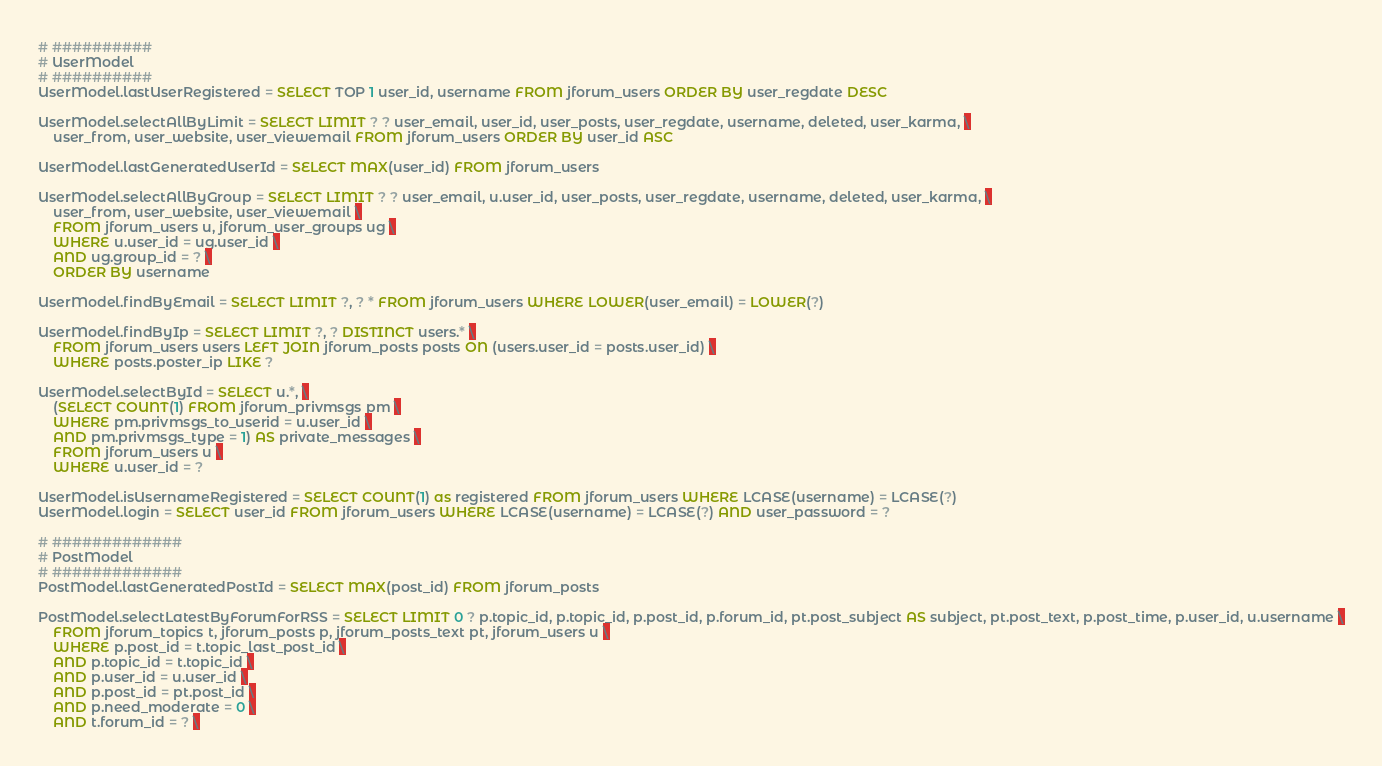Convert code to text. <code><loc_0><loc_0><loc_500><loc_500><_SQL_># ##########
# UserModel
# ##########
UserModel.lastUserRegistered = SELECT TOP 1 user_id, username FROM jforum_users ORDER BY user_regdate DESC 

UserModel.selectAllByLimit = SELECT LIMIT ? ? user_email, user_id, user_posts, user_regdate, username, deleted, user_karma, \
	user_from, user_website, user_viewemail FROM jforum_users ORDER BY user_id ASC

UserModel.lastGeneratedUserId = SELECT MAX(user_id) FROM jforum_users

UserModel.selectAllByGroup = SELECT LIMIT ? ? user_email, u.user_id, user_posts, user_regdate, username, deleted, user_karma, \
	user_from, user_website, user_viewemail \
	FROM jforum_users u, jforum_user_groups ug \
	WHERE u.user_id = ug.user_id \
	AND ug.group_id = ? \
	ORDER BY username

UserModel.findByEmail = SELECT LIMIT ?, ? * FROM jforum_users WHERE LOWER(user_email) = LOWER(?)

UserModel.findByIp = SELECT LIMIT ?, ? DISTINCT users.* \
    FROM jforum_users users LEFT JOIN jforum_posts posts ON (users.user_id = posts.user_id) \
    WHERE posts.poster_ip LIKE ?
    	
UserModel.selectById = SELECT u.*, \
	(SELECT COUNT(1) FROM jforum_privmsgs pm \
	WHERE pm.privmsgs_to_userid = u.user_id \
	AND pm.privmsgs_type = 1) AS private_messages \
	FROM jforum_users u \
	WHERE u.user_id = ?

UserModel.isUsernameRegistered = SELECT COUNT(1) as registered FROM jforum_users WHERE LCASE(username) = LCASE(?)
UserModel.login = SELECT user_id FROM jforum_users WHERE LCASE(username) = LCASE(?) AND user_password = ?

# #############
# PostModel
# #############
PostModel.lastGeneratedPostId = SELECT MAX(post_id) FROM jforum_posts
	
PostModel.selectLatestByForumForRSS = SELECT LIMIT 0 ? p.topic_id, p.topic_id, p.post_id, p.forum_id, pt.post_subject AS subject, pt.post_text, p.post_time, p.user_id, u.username \
	FROM jforum_topics t, jforum_posts p, jforum_posts_text pt, jforum_users u \
	WHERE p.post_id = t.topic_last_post_id \
	AND p.topic_id = t.topic_id \
	AND p.user_id = u.user_id \
	AND p.post_id = pt.post_id \
	AND p.need_moderate = 0 \
	AND t.forum_id = ? \</code> 